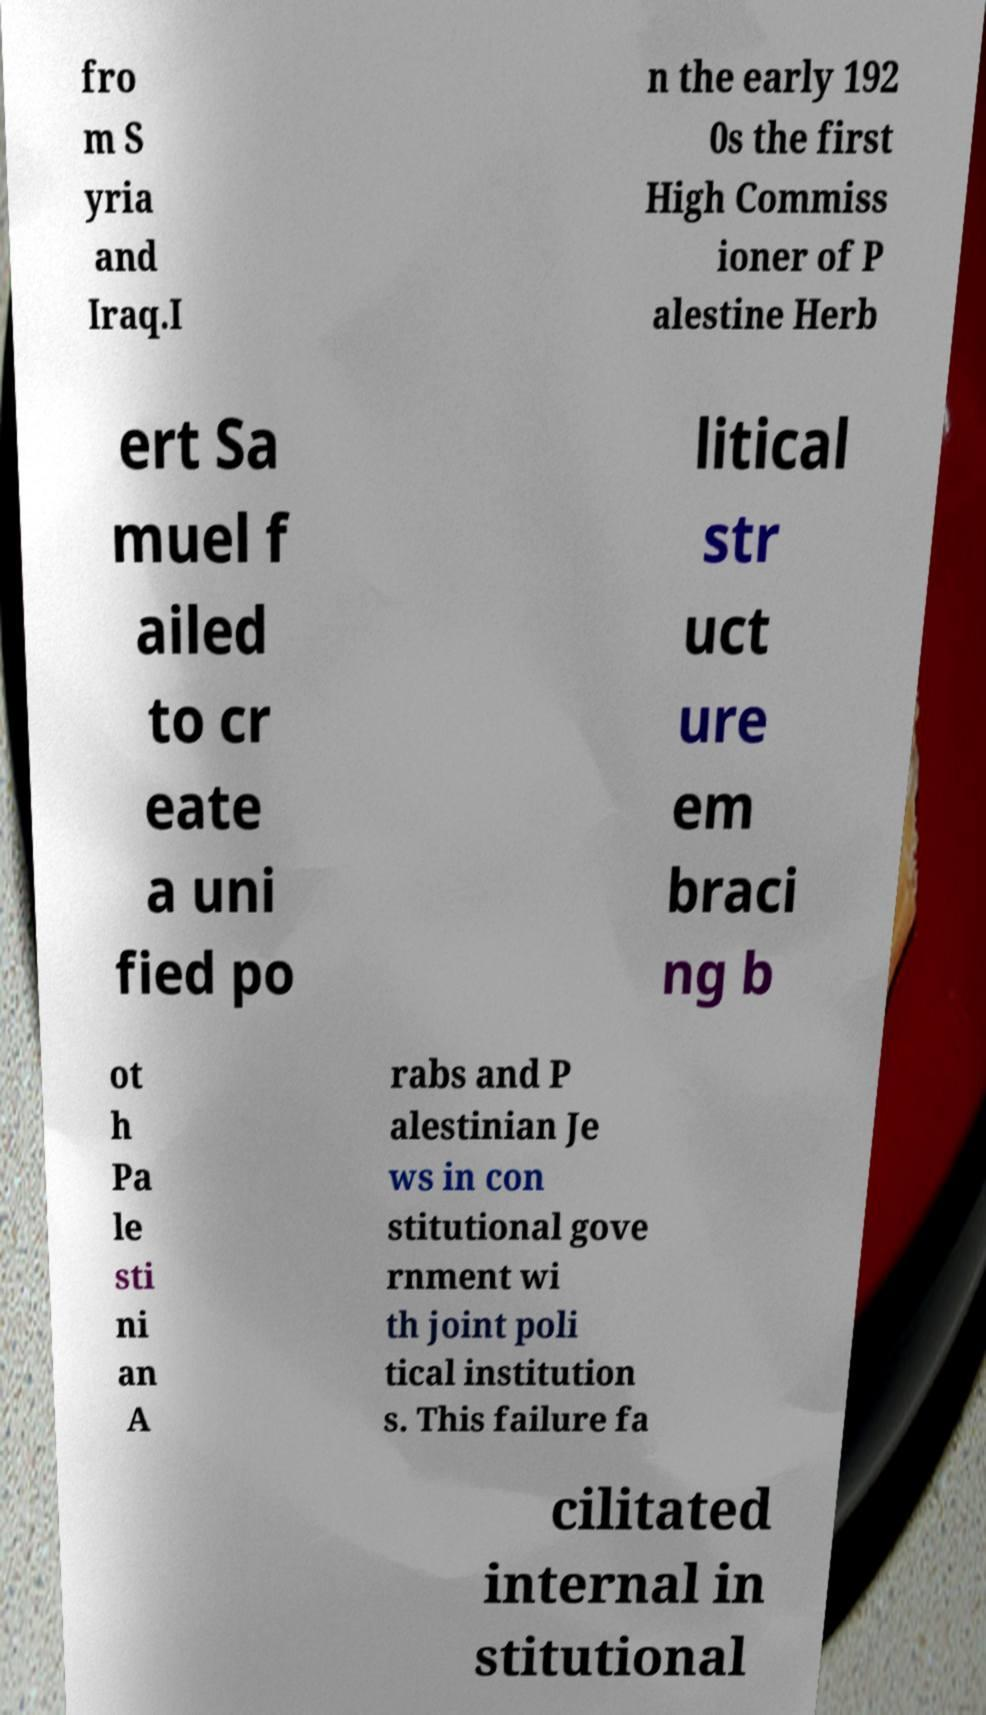Could you extract and type out the text from this image? fro m S yria and Iraq.I n the early 192 0s the first High Commiss ioner of P alestine Herb ert Sa muel f ailed to cr eate a uni fied po litical str uct ure em braci ng b ot h Pa le sti ni an A rabs and P alestinian Je ws in con stitutional gove rnment wi th joint poli tical institution s. This failure fa cilitated internal in stitutional 